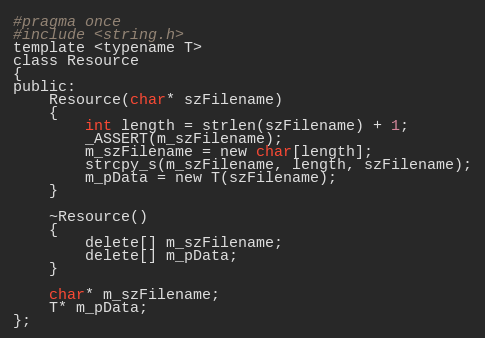Convert code to text. <code><loc_0><loc_0><loc_500><loc_500><_C_>#pragma once
#include <string.h>
template <typename T>
class Resource
{
public:
	Resource(char* szFilename)
	{
		int length = strlen(szFilename) + 1;
		_ASSERT(m_szFilename);
		m_szFilename = new char[length];
		strcpy_s(m_szFilename, length, szFilename);
		m_pData = new T(szFilename);
	}

	~Resource()
	{
		delete[] m_szFilename;
		delete[] m_pData;
	}

	char* m_szFilename;
	T* m_pData;
};</code> 